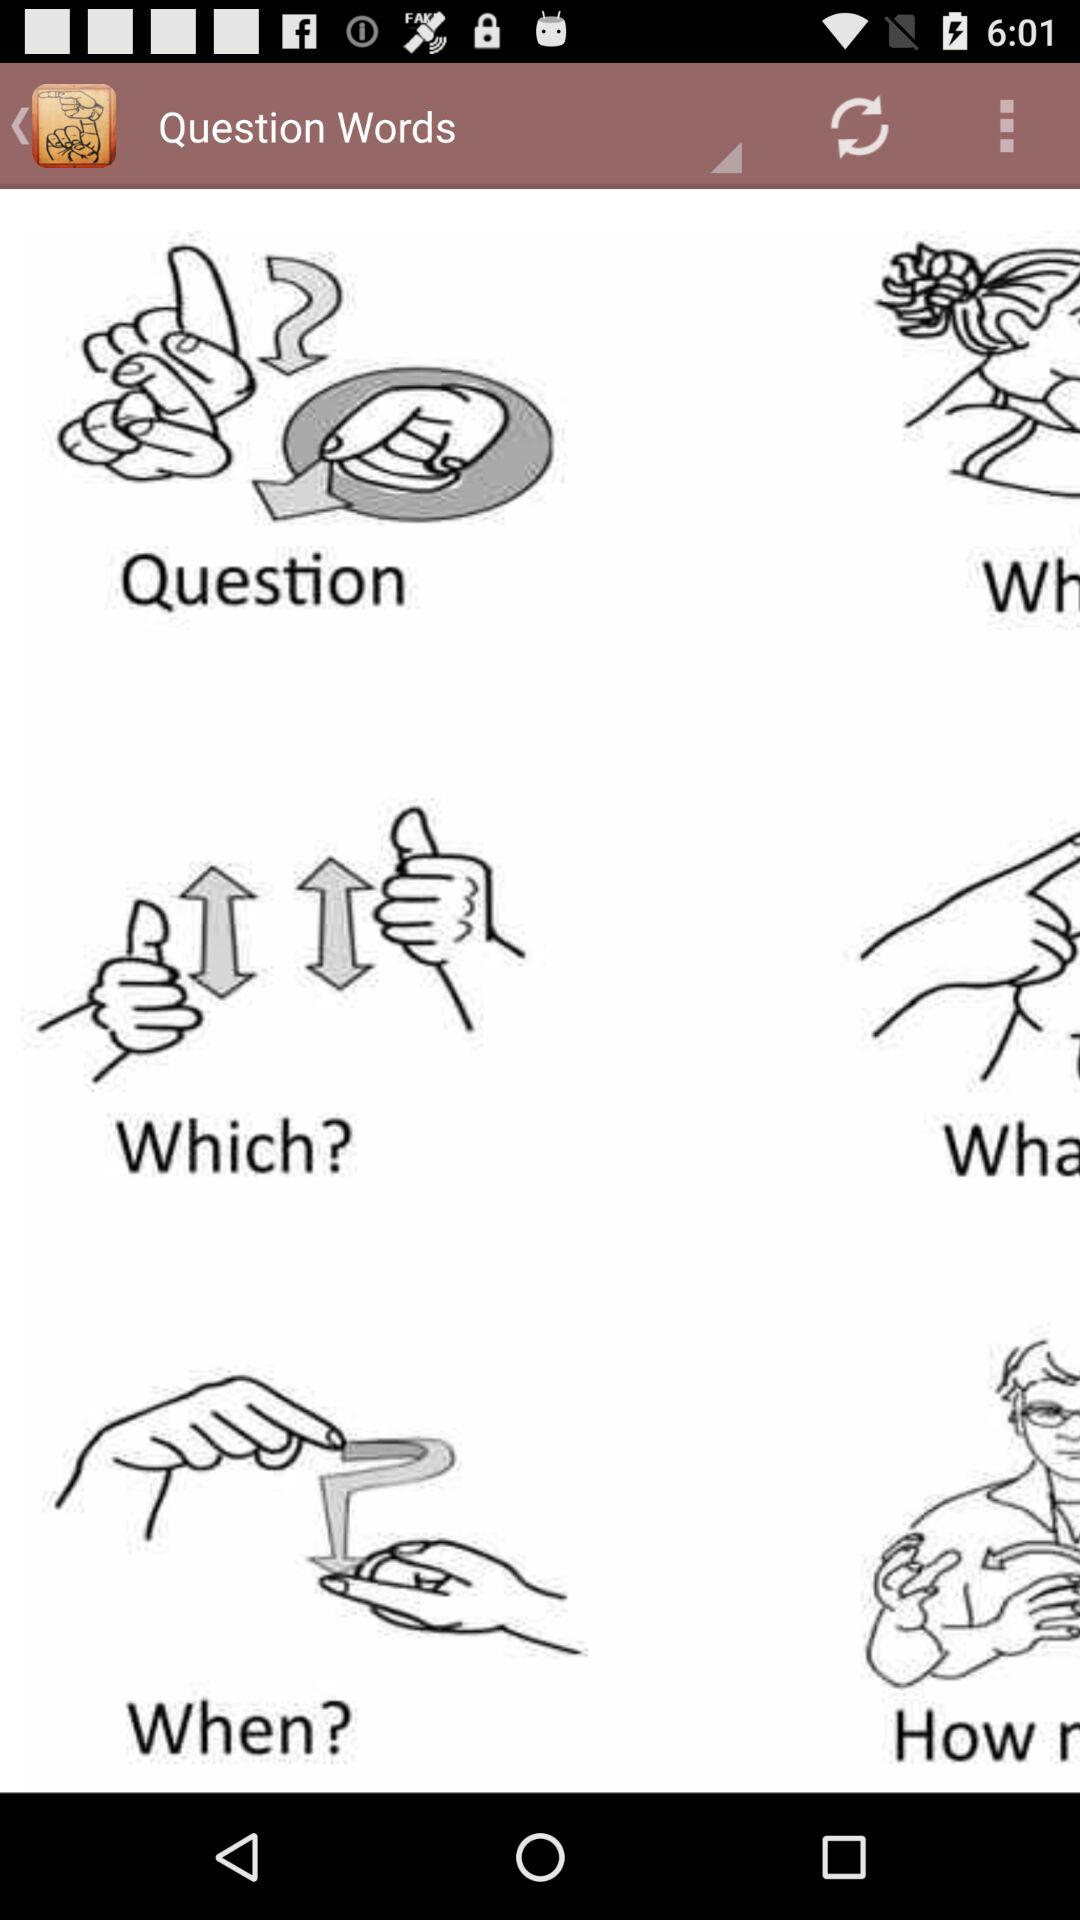What is the application name? The application name is "Question Words". 